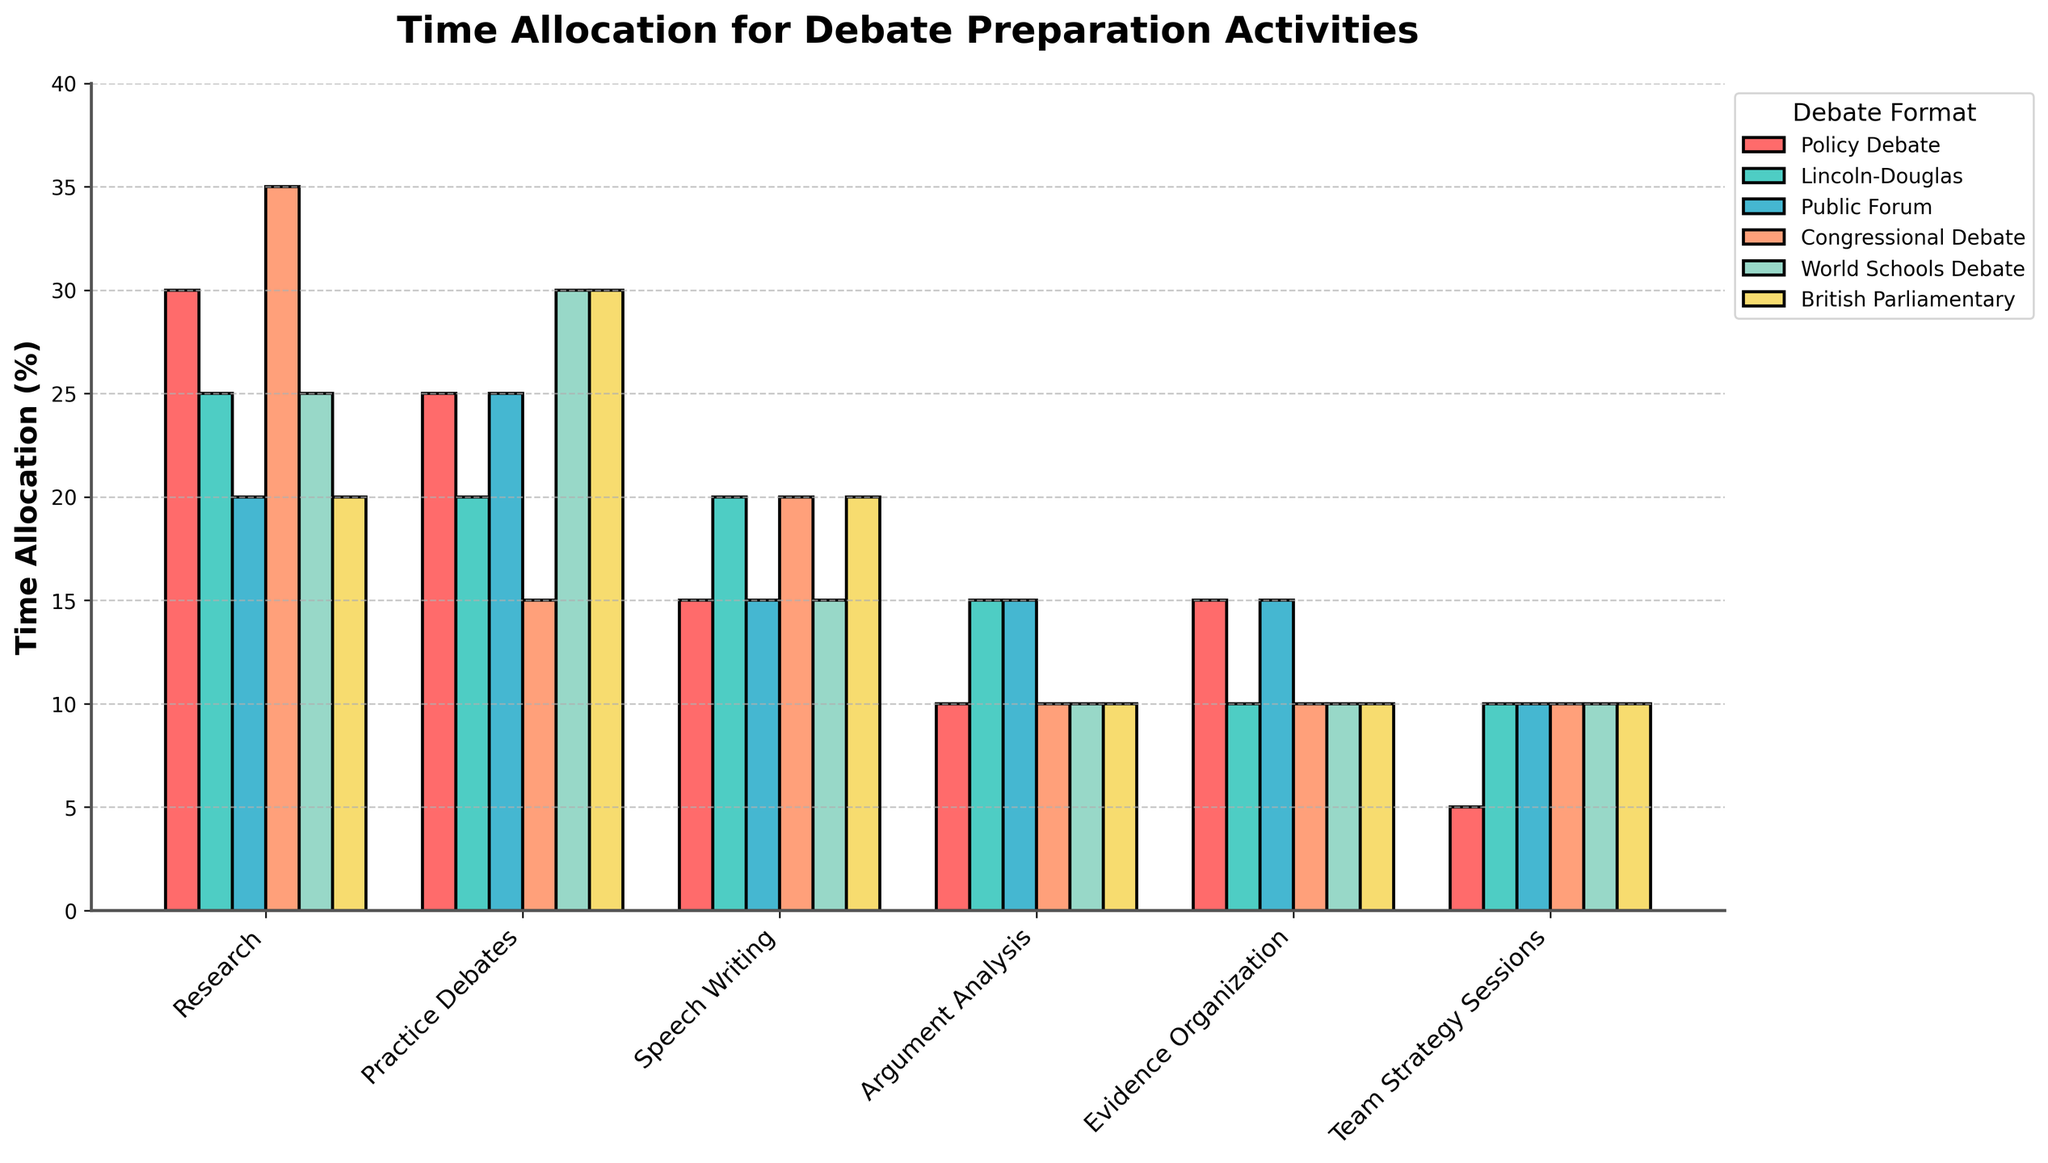what's the total time allocated for Evidence Organization in all debate formats? Sum up the percentages for Evidence Organization across all debate formats: Policy Debate (15) + Lincoln-Douglas (10) + Public Forum (15) + Congressional Debate (10) + World Schools Debate (10) + British Parliamentary (10). This gives us 15 + 10 + 15 + 10 + 10 + 10 = 70
Answer: 70 Which debate format spends the most time on Research? Look for the highest bar in the Research category. In this case, the Policy Debate format has the highest Research allocation with a value of 30.
Answer: Policy Debate How much more time does Congressional Debate allocate to Research compared to Practice Debates? Congressional Debate allocates 35% to Research and 15% to Practice Debates. Subtract the latter from the former: 35 - 15 = 20
Answer: 20 Which debate format spends equal time on Argument Analysis and Team Strategy Sessions? Examine the bars for Argument Analysis and Team Strategy Sessions. The Lincoln-Douglas format allocates 15% for Argument Analysis and 10% for Team Strategy Sessions. Similarly, Public Forum allocates 15% for Argument Analysis and 10% for Team Strategy Sessions. Both have equal values for both activities.
Answer: Lincoln-Douglas, Public Forum What's the average time allocation for Practice Debates across all debate formats? Sum up the time allocations for Practice Debates and divide by the number of debate formats: (25 + 20 + 25 + 15 + 30 + 30) / 6 = 145 / 6 ≈ 24.17
Answer: 24.17 In which activity do the World Schools and British Parliamentary formats spend the same amount of time? Look for activities where the heights of the corresponding bars in both formats match. Both World Schools Debate and British Parliamentary spend 30% on Practice Debates. Also, they both spend 10% on Team Strategy Sessions, Argument Analysis, and Evidence Organization.
Answer: Practice Debates, Team Strategy Sessions, Argument Analysis, Evidence Organization Which activity has the least variation in time allocation across all debate formats? Compare the ranges of each activity (highest value minus lowest value). Research ranges from 20 to 35, Practice Debates from 15 to 30, Speech Writing and Argument Analysis from 10 to 20, Evidence Organization from 10 to 15, and Team Strategy Sessions from 5 to 10. Team Strategy Sessions have the least variation, from 5 to 10, a range of 5.
Answer: Team Strategy Sessions 